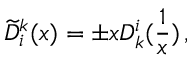<formula> <loc_0><loc_0><loc_500><loc_500>\widetilde { D } _ { i } ^ { k } ( x ) = \pm x D _ { k } ^ { i } ( \frac { 1 } { x } ) \, ,</formula> 